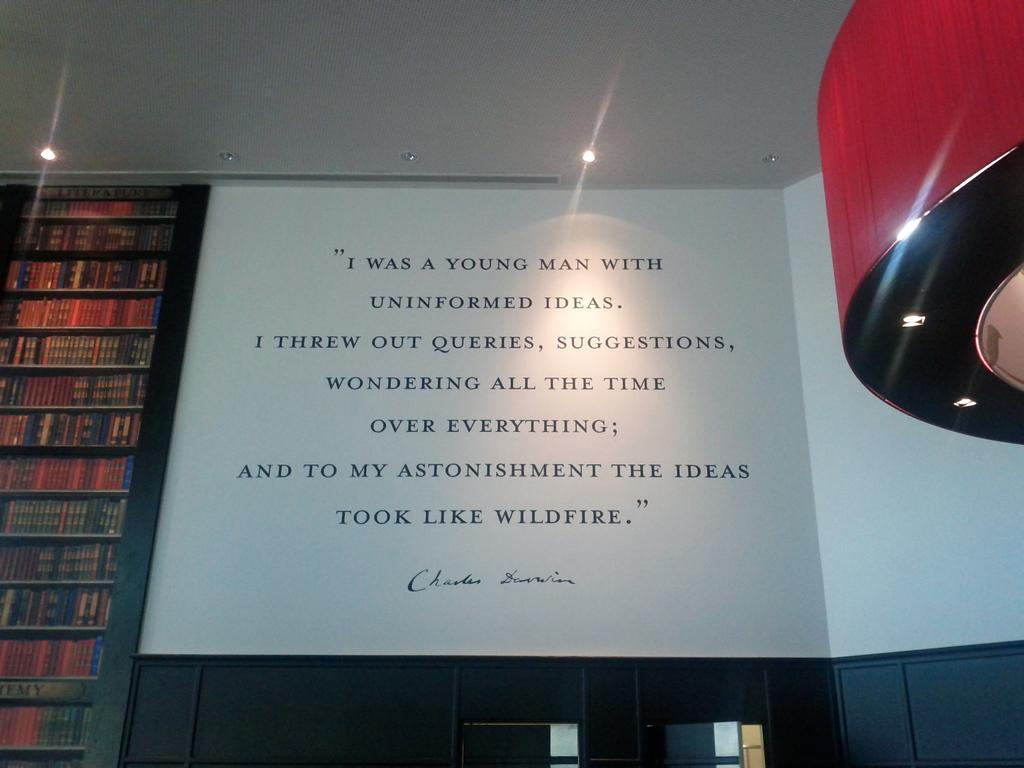<image>
Describe the image concisely. Large sign on a wall that was written by someone named Charles. 